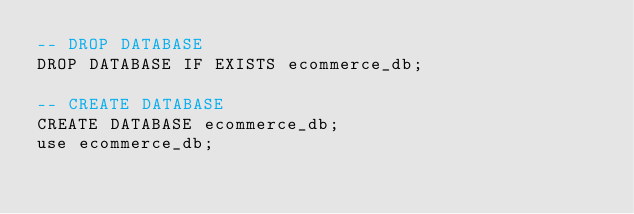<code> <loc_0><loc_0><loc_500><loc_500><_SQL_>-- DROP DATABASE
DROP DATABASE IF EXISTS ecommerce_db;

-- CREATE DATABASE
CREATE DATABASE ecommerce_db;
use ecommerce_db;
</code> 